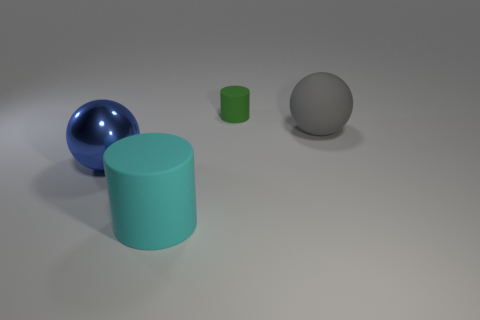Is the number of matte cylinders that are behind the cyan matte thing the same as the number of big cyan cylinders that are on the left side of the large blue thing?
Your answer should be compact. No. What shape is the big thing behind the sphere to the left of the big rubber thing that is on the right side of the large matte cylinder?
Give a very brief answer. Sphere. Are the ball behind the metal sphere and the big thing in front of the big blue metal ball made of the same material?
Give a very brief answer. Yes. There is a big matte object behind the large metal sphere; what shape is it?
Offer a terse response. Sphere. Is the number of big blue metallic spheres less than the number of spheres?
Make the answer very short. Yes. Is there a big rubber thing to the right of the cylinder in front of the matte thing behind the big gray matte thing?
Ensure brevity in your answer.  Yes. What number of rubber objects are yellow objects or blue spheres?
Your answer should be very brief. 0. Is the large shiny ball the same color as the small object?
Your response must be concise. No. There is a green rubber thing; what number of cylinders are in front of it?
Make the answer very short. 1. What number of objects are both right of the blue metallic sphere and in front of the tiny green matte cylinder?
Ensure brevity in your answer.  2. 